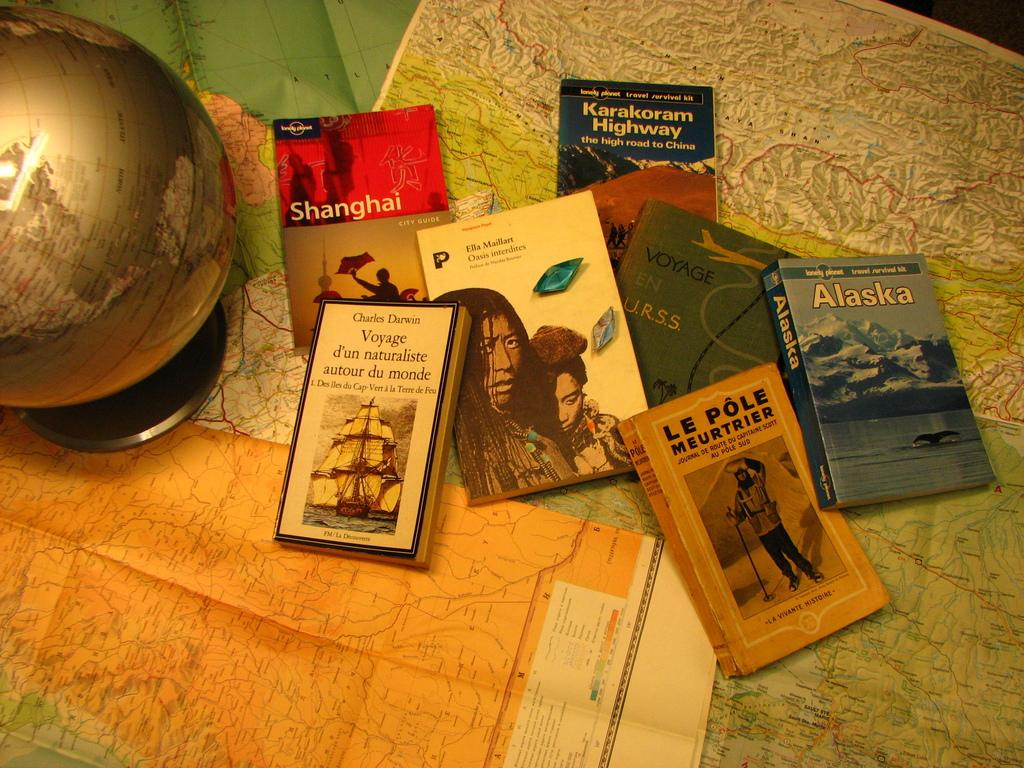<image>
Describe the image concisely. A travel book about Alaska sits with some other travel books on top of a map. 